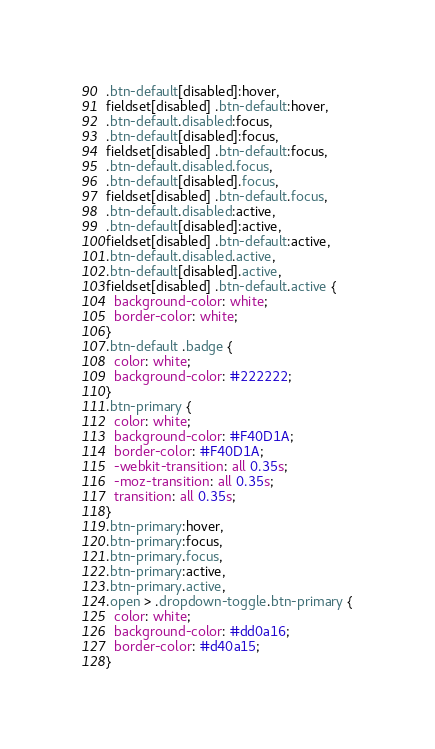Convert code to text. <code><loc_0><loc_0><loc_500><loc_500><_CSS_>.btn-default[disabled]:hover,
fieldset[disabled] .btn-default:hover,
.btn-default.disabled:focus,
.btn-default[disabled]:focus,
fieldset[disabled] .btn-default:focus,
.btn-default.disabled.focus,
.btn-default[disabled].focus,
fieldset[disabled] .btn-default.focus,
.btn-default.disabled:active,
.btn-default[disabled]:active,
fieldset[disabled] .btn-default:active,
.btn-default.disabled.active,
.btn-default[disabled].active,
fieldset[disabled] .btn-default.active {
  background-color: white;
  border-color: white;
}
.btn-default .badge {
  color: white;
  background-color: #222222;
}
.btn-primary {
  color: white;
  background-color: #F40D1A;
  border-color: #F40D1A;
  -webkit-transition: all 0.35s;
  -moz-transition: all 0.35s;
  transition: all 0.35s;
}
.btn-primary:hover,
.btn-primary:focus,
.btn-primary.focus,
.btn-primary:active,
.btn-primary.active,
.open > .dropdown-toggle.btn-primary {
  color: white;
  background-color: #dd0a16;
  border-color: #d40a15;
}</code> 